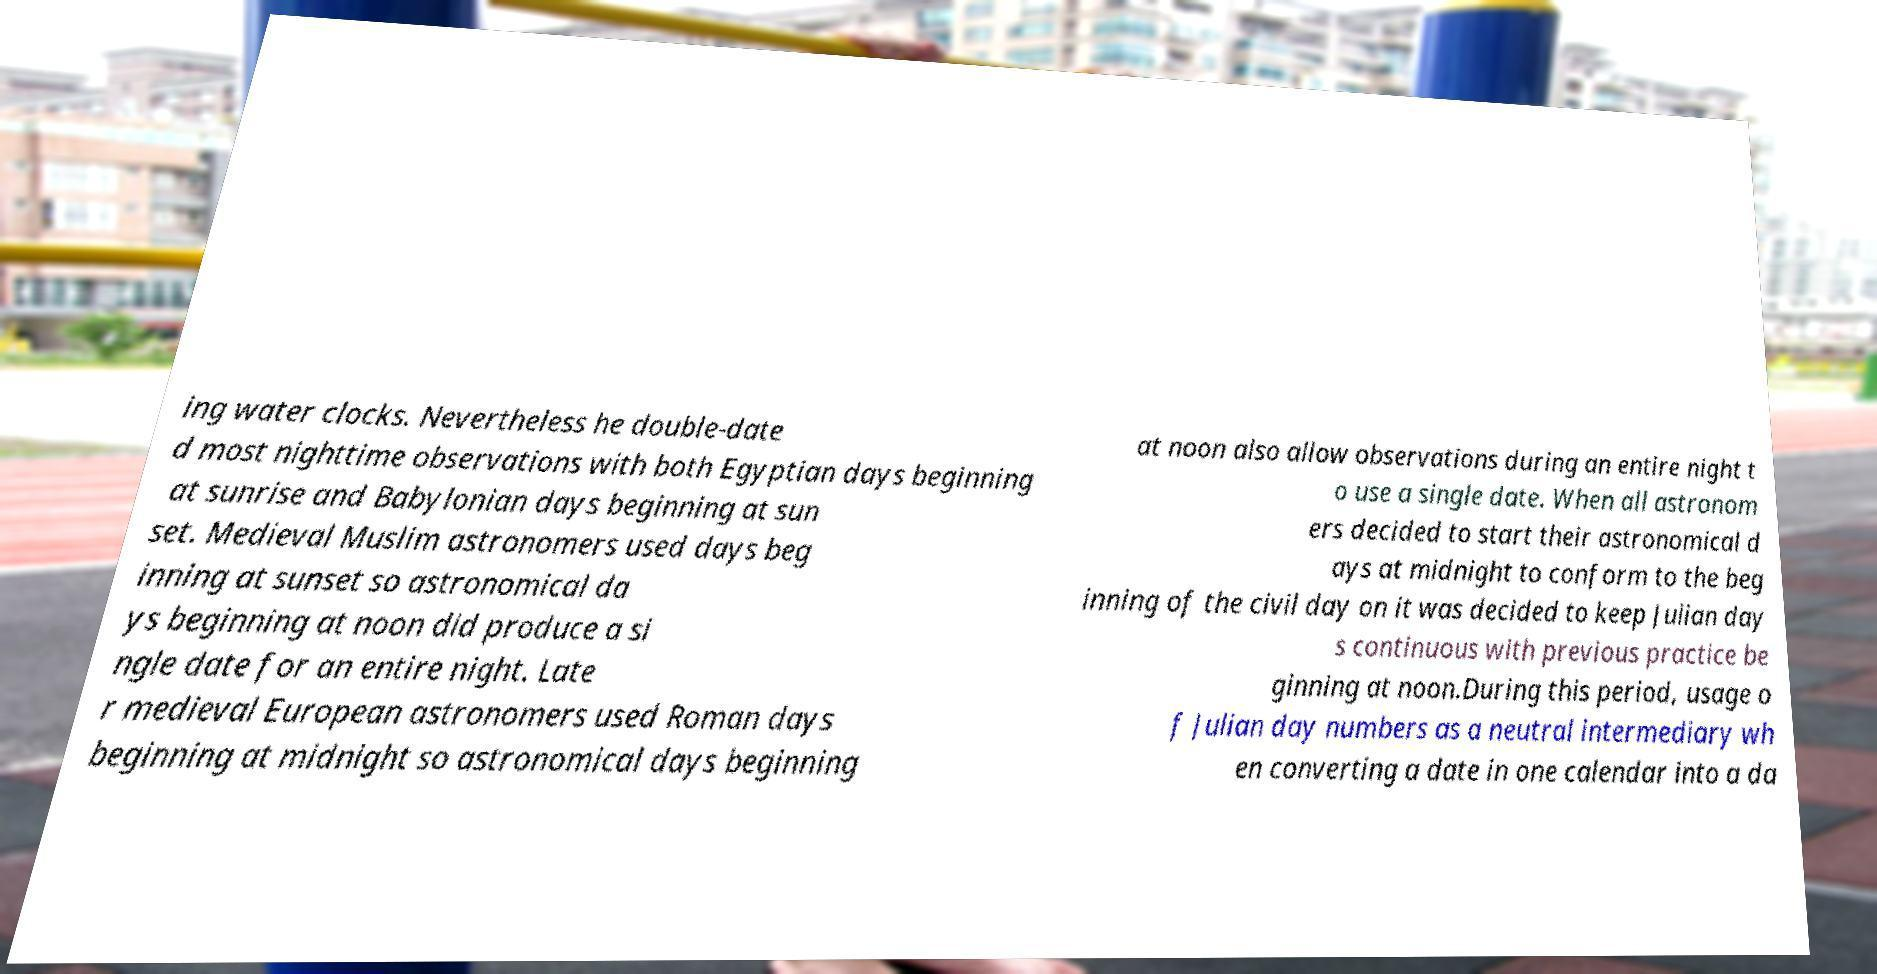Could you extract and type out the text from this image? ing water clocks. Nevertheless he double-date d most nighttime observations with both Egyptian days beginning at sunrise and Babylonian days beginning at sun set. Medieval Muslim astronomers used days beg inning at sunset so astronomical da ys beginning at noon did produce a si ngle date for an entire night. Late r medieval European astronomers used Roman days beginning at midnight so astronomical days beginning at noon also allow observations during an entire night t o use a single date. When all astronom ers decided to start their astronomical d ays at midnight to conform to the beg inning of the civil day on it was decided to keep Julian day s continuous with previous practice be ginning at noon.During this period, usage o f Julian day numbers as a neutral intermediary wh en converting a date in one calendar into a da 